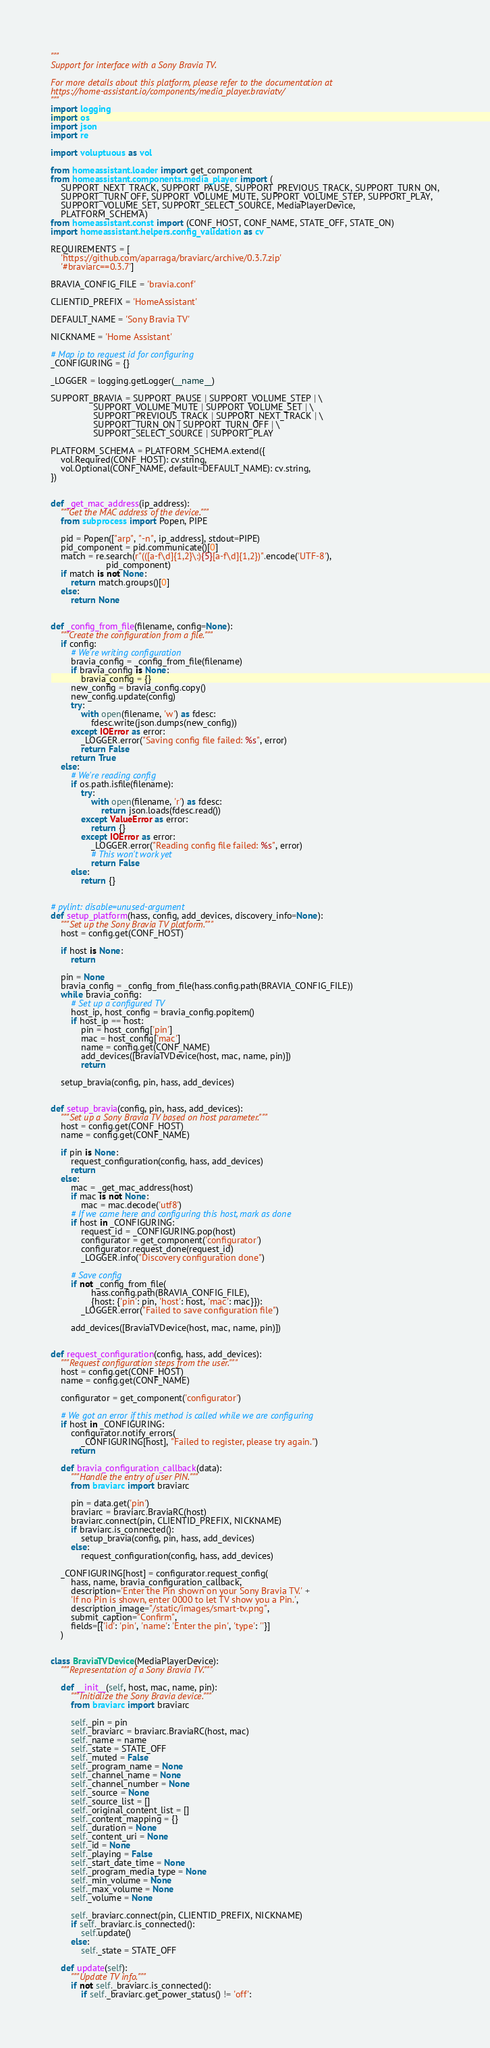<code> <loc_0><loc_0><loc_500><loc_500><_Python_>"""
Support for interface with a Sony Bravia TV.

For more details about this platform, please refer to the documentation at
https://home-assistant.io/components/media_player.braviatv/
"""
import logging
import os
import json
import re

import voluptuous as vol

from homeassistant.loader import get_component
from homeassistant.components.media_player import (
    SUPPORT_NEXT_TRACK, SUPPORT_PAUSE, SUPPORT_PREVIOUS_TRACK, SUPPORT_TURN_ON,
    SUPPORT_TURN_OFF, SUPPORT_VOLUME_MUTE, SUPPORT_VOLUME_STEP, SUPPORT_PLAY,
    SUPPORT_VOLUME_SET, SUPPORT_SELECT_SOURCE, MediaPlayerDevice,
    PLATFORM_SCHEMA)
from homeassistant.const import (CONF_HOST, CONF_NAME, STATE_OFF, STATE_ON)
import homeassistant.helpers.config_validation as cv

REQUIREMENTS = [
    'https://github.com/aparraga/braviarc/archive/0.3.7.zip'
    '#braviarc==0.3.7']

BRAVIA_CONFIG_FILE = 'bravia.conf'

CLIENTID_PREFIX = 'HomeAssistant'

DEFAULT_NAME = 'Sony Bravia TV'

NICKNAME = 'Home Assistant'

# Map ip to request id for configuring
_CONFIGURING = {}

_LOGGER = logging.getLogger(__name__)

SUPPORT_BRAVIA = SUPPORT_PAUSE | SUPPORT_VOLUME_STEP | \
                 SUPPORT_VOLUME_MUTE | SUPPORT_VOLUME_SET | \
                 SUPPORT_PREVIOUS_TRACK | SUPPORT_NEXT_TRACK | \
                 SUPPORT_TURN_ON | SUPPORT_TURN_OFF | \
                 SUPPORT_SELECT_SOURCE | SUPPORT_PLAY

PLATFORM_SCHEMA = PLATFORM_SCHEMA.extend({
    vol.Required(CONF_HOST): cv.string,
    vol.Optional(CONF_NAME, default=DEFAULT_NAME): cv.string,
})


def _get_mac_address(ip_address):
    """Get the MAC address of the device."""
    from subprocess import Popen, PIPE

    pid = Popen(["arp", "-n", ip_address], stdout=PIPE)
    pid_component = pid.communicate()[0]
    match = re.search(r"(([a-f\d]{1,2}\:){5}[a-f\d]{1,2})".encode('UTF-8'),
                      pid_component)
    if match is not None:
        return match.groups()[0]
    else:
        return None


def _config_from_file(filename, config=None):
    """Create the configuration from a file."""
    if config:
        # We're writing configuration
        bravia_config = _config_from_file(filename)
        if bravia_config is None:
            bravia_config = {}
        new_config = bravia_config.copy()
        new_config.update(config)
        try:
            with open(filename, 'w') as fdesc:
                fdesc.write(json.dumps(new_config))
        except IOError as error:
            _LOGGER.error("Saving config file failed: %s", error)
            return False
        return True
    else:
        # We're reading config
        if os.path.isfile(filename):
            try:
                with open(filename, 'r') as fdesc:
                    return json.loads(fdesc.read())
            except ValueError as error:
                return {}
            except IOError as error:
                _LOGGER.error("Reading config file failed: %s", error)
                # This won't work yet
                return False
        else:
            return {}


# pylint: disable=unused-argument
def setup_platform(hass, config, add_devices, discovery_info=None):
    """Set up the Sony Bravia TV platform."""
    host = config.get(CONF_HOST)

    if host is None:
        return

    pin = None
    bravia_config = _config_from_file(hass.config.path(BRAVIA_CONFIG_FILE))
    while bravia_config:
        # Set up a configured TV
        host_ip, host_config = bravia_config.popitem()
        if host_ip == host:
            pin = host_config['pin']
            mac = host_config['mac']
            name = config.get(CONF_NAME)
            add_devices([BraviaTVDevice(host, mac, name, pin)])
            return

    setup_bravia(config, pin, hass, add_devices)


def setup_bravia(config, pin, hass, add_devices):
    """Set up a Sony Bravia TV based on host parameter."""
    host = config.get(CONF_HOST)
    name = config.get(CONF_NAME)

    if pin is None:
        request_configuration(config, hass, add_devices)
        return
    else:
        mac = _get_mac_address(host)
        if mac is not None:
            mac = mac.decode('utf8')
        # If we came here and configuring this host, mark as done
        if host in _CONFIGURING:
            request_id = _CONFIGURING.pop(host)
            configurator = get_component('configurator')
            configurator.request_done(request_id)
            _LOGGER.info("Discovery configuration done")

        # Save config
        if not _config_from_file(
                hass.config.path(BRAVIA_CONFIG_FILE),
                {host: {'pin': pin, 'host': host, 'mac': mac}}):
            _LOGGER.error("Failed to save configuration file")

        add_devices([BraviaTVDevice(host, mac, name, pin)])


def request_configuration(config, hass, add_devices):
    """Request configuration steps from the user."""
    host = config.get(CONF_HOST)
    name = config.get(CONF_NAME)

    configurator = get_component('configurator')

    # We got an error if this method is called while we are configuring
    if host in _CONFIGURING:
        configurator.notify_errors(
            _CONFIGURING[host], "Failed to register, please try again.")
        return

    def bravia_configuration_callback(data):
        """Handle the entry of user PIN."""
        from braviarc import braviarc

        pin = data.get('pin')
        braviarc = braviarc.BraviaRC(host)
        braviarc.connect(pin, CLIENTID_PREFIX, NICKNAME)
        if braviarc.is_connected():
            setup_bravia(config, pin, hass, add_devices)
        else:
            request_configuration(config, hass, add_devices)

    _CONFIGURING[host] = configurator.request_config(
        hass, name, bravia_configuration_callback,
        description='Enter the Pin shown on your Sony Bravia TV.' +
        'If no Pin is shown, enter 0000 to let TV show you a Pin.',
        description_image="/static/images/smart-tv.png",
        submit_caption="Confirm",
        fields=[{'id': 'pin', 'name': 'Enter the pin', 'type': ''}]
    )


class BraviaTVDevice(MediaPlayerDevice):
    """Representation of a Sony Bravia TV."""

    def __init__(self, host, mac, name, pin):
        """Initialize the Sony Bravia device."""
        from braviarc import braviarc

        self._pin = pin
        self._braviarc = braviarc.BraviaRC(host, mac)
        self._name = name
        self._state = STATE_OFF
        self._muted = False
        self._program_name = None
        self._channel_name = None
        self._channel_number = None
        self._source = None
        self._source_list = []
        self._original_content_list = []
        self._content_mapping = {}
        self._duration = None
        self._content_uri = None
        self._id = None
        self._playing = False
        self._start_date_time = None
        self._program_media_type = None
        self._min_volume = None
        self._max_volume = None
        self._volume = None

        self._braviarc.connect(pin, CLIENTID_PREFIX, NICKNAME)
        if self._braviarc.is_connected():
            self.update()
        else:
            self._state = STATE_OFF

    def update(self):
        """Update TV info."""
        if not self._braviarc.is_connected():
            if self._braviarc.get_power_status() != 'off':</code> 